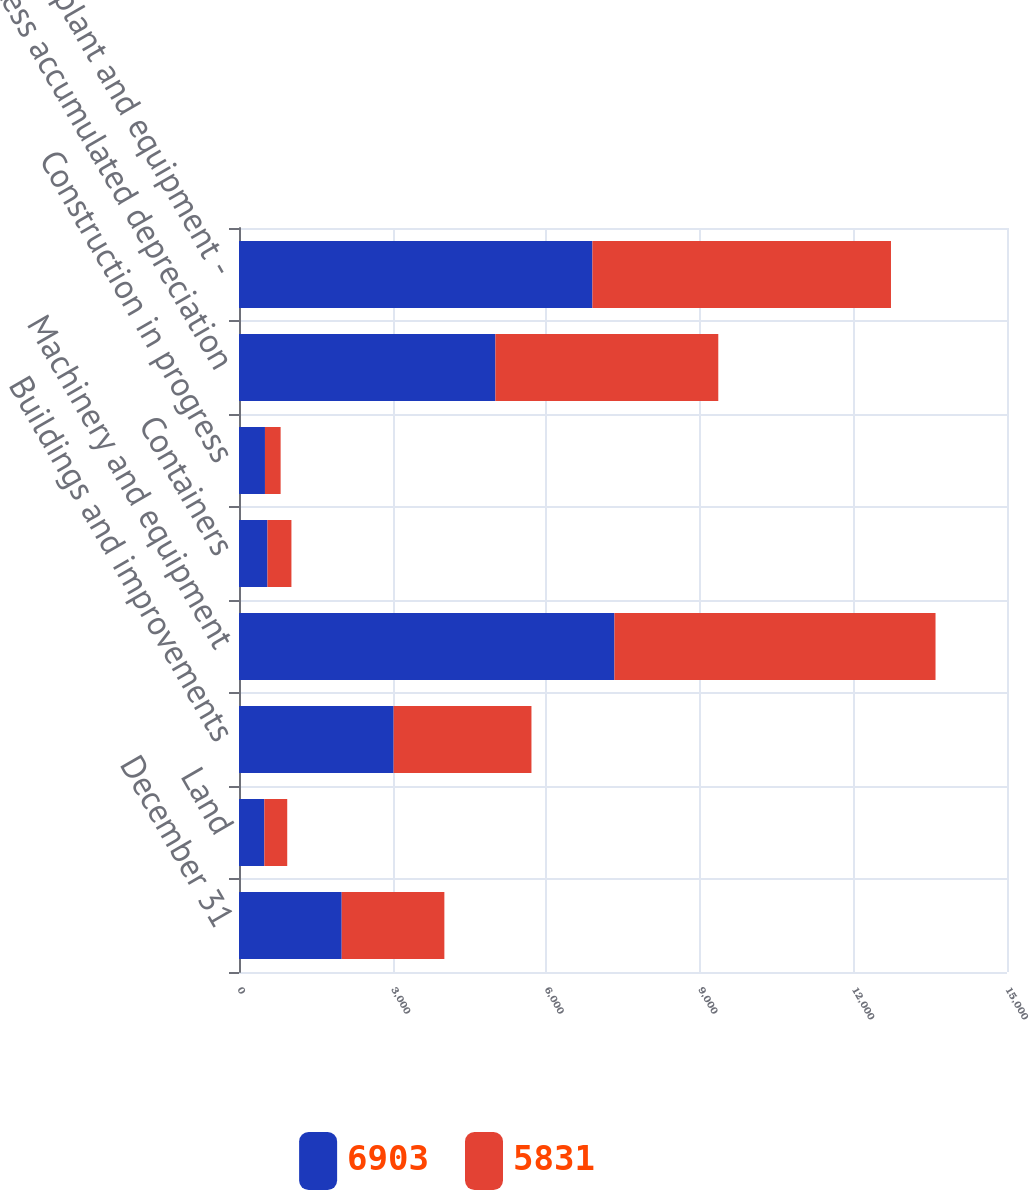Convert chart to OTSL. <chart><loc_0><loc_0><loc_500><loc_500><stacked_bar_chart><ecel><fcel>December 31<fcel>Land<fcel>Buildings and improvements<fcel>Machinery and equipment<fcel>Containers<fcel>Construction in progress<fcel>Less accumulated depreciation<fcel>Property plant and equipment -<nl><fcel>6903<fcel>2006<fcel>495<fcel>3020<fcel>7333<fcel>556<fcel>507<fcel>5008<fcel>6903<nl><fcel>5831<fcel>2005<fcel>447<fcel>2692<fcel>6271<fcel>468<fcel>306<fcel>4353<fcel>5831<nl></chart> 